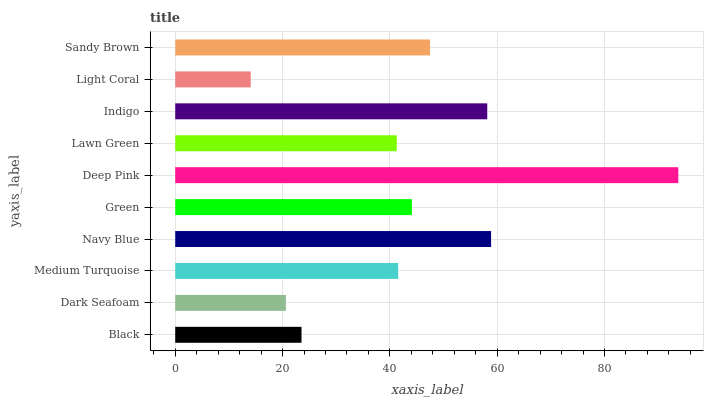Is Light Coral the minimum?
Answer yes or no. Yes. Is Deep Pink the maximum?
Answer yes or no. Yes. Is Dark Seafoam the minimum?
Answer yes or no. No. Is Dark Seafoam the maximum?
Answer yes or no. No. Is Black greater than Dark Seafoam?
Answer yes or no. Yes. Is Dark Seafoam less than Black?
Answer yes or no. Yes. Is Dark Seafoam greater than Black?
Answer yes or no. No. Is Black less than Dark Seafoam?
Answer yes or no. No. Is Green the high median?
Answer yes or no. Yes. Is Medium Turquoise the low median?
Answer yes or no. Yes. Is Deep Pink the high median?
Answer yes or no. No. Is Sandy Brown the low median?
Answer yes or no. No. 